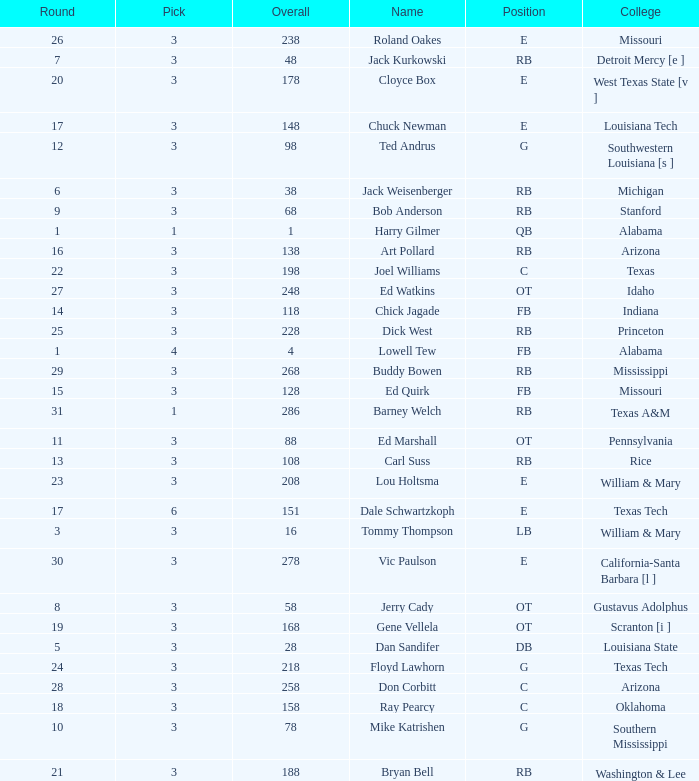How much Overall has a Name of bob anderson? 1.0. 